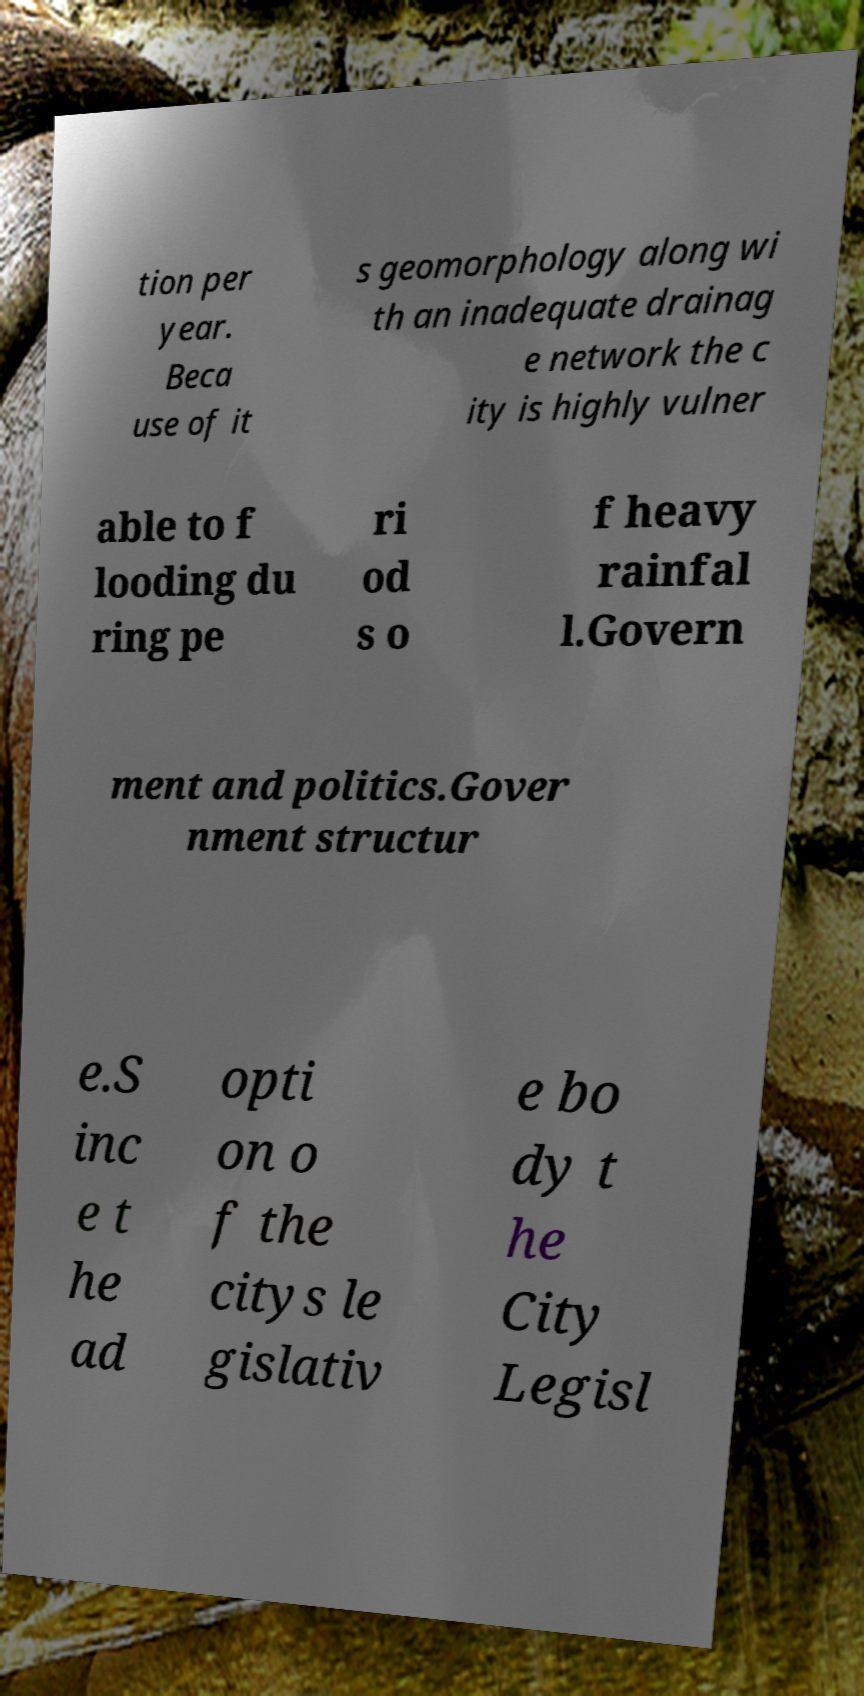Can you accurately transcribe the text from the provided image for me? tion per year. Beca use of it s geomorphology along wi th an inadequate drainag e network the c ity is highly vulner able to f looding du ring pe ri od s o f heavy rainfal l.Govern ment and politics.Gover nment structur e.S inc e t he ad opti on o f the citys le gislativ e bo dy t he City Legisl 